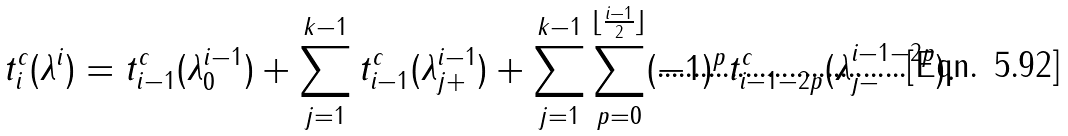<formula> <loc_0><loc_0><loc_500><loc_500>t ^ { c } _ { i } ( \lambda ^ { i } ) = t ^ { c } _ { i - 1 } ( \lambda _ { 0 } ^ { i - 1 } ) + \sum _ { j = 1 } ^ { k - 1 } t ^ { c } _ { i - 1 } ( \lambda ^ { i - 1 } _ { j + } ) + \sum _ { j = 1 } ^ { k - 1 } \sum _ { p = 0 } ^ { \lfloor \frac { i - 1 } { 2 } \rfloor } ( - 1 ) ^ { p } t ^ { c } _ { i - 1 - 2 p } ( \lambda ^ { i - 1 - 2 p } _ { j - } ) .</formula> 